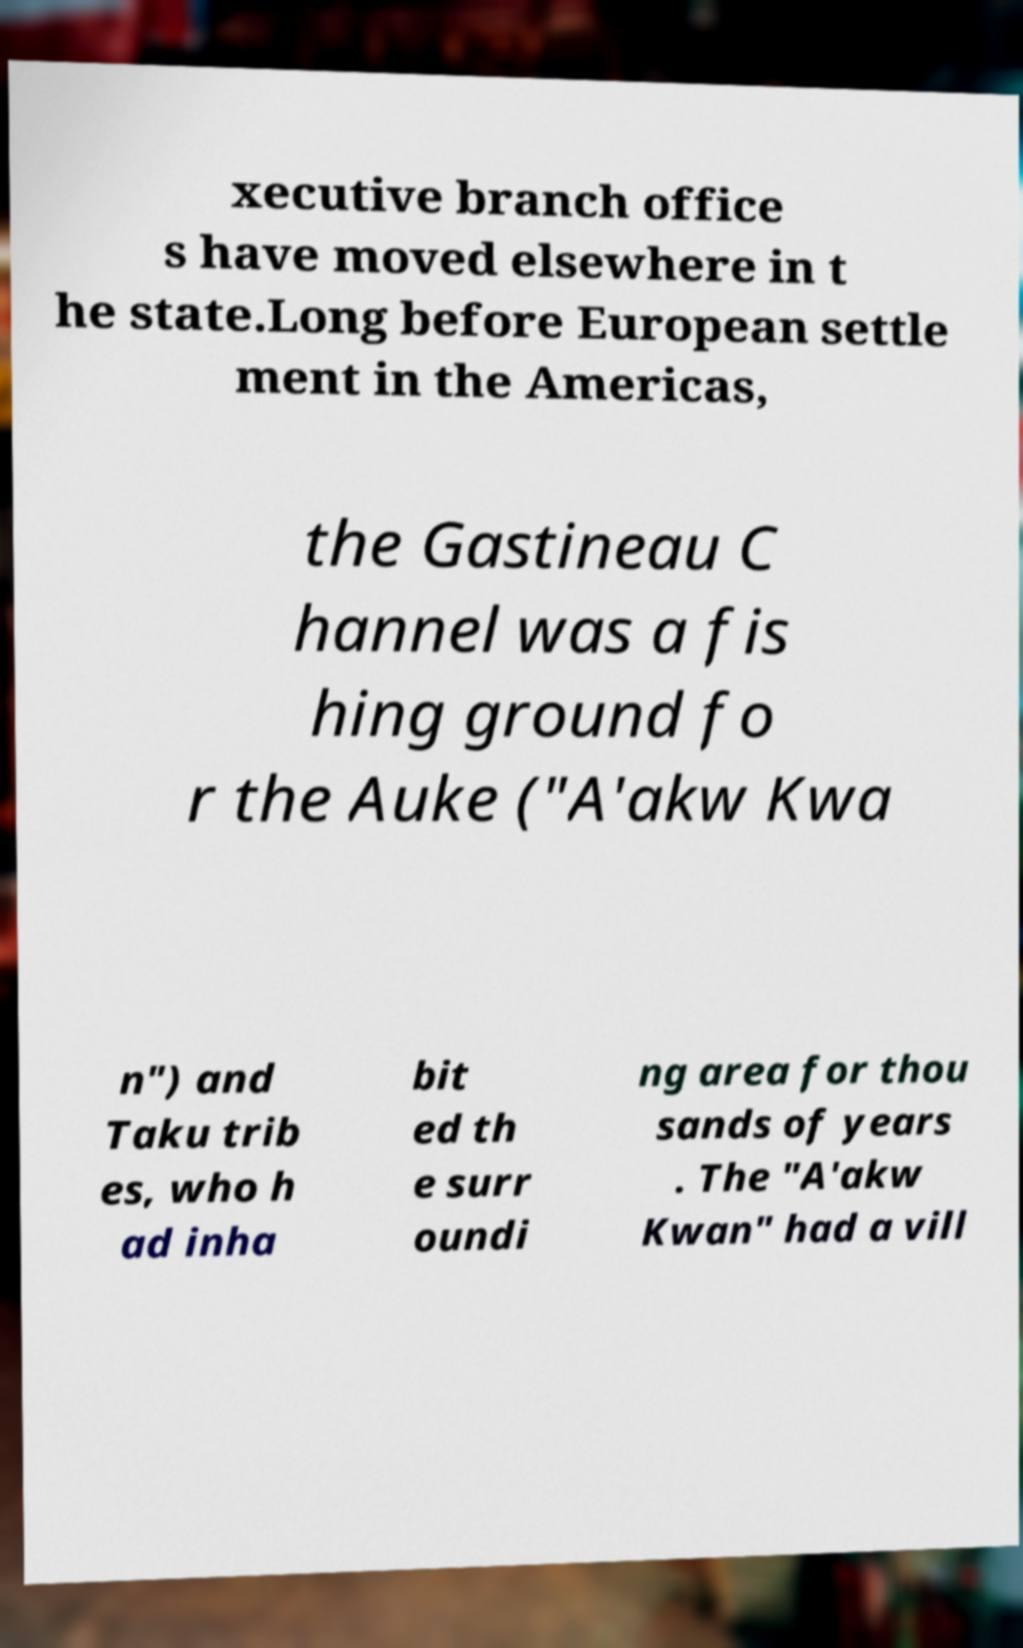Could you extract and type out the text from this image? xecutive branch office s have moved elsewhere in t he state.Long before European settle ment in the Americas, the Gastineau C hannel was a fis hing ground fo r the Auke ("A'akw Kwa n") and Taku trib es, who h ad inha bit ed th e surr oundi ng area for thou sands of years . The "A'akw Kwan" had a vill 